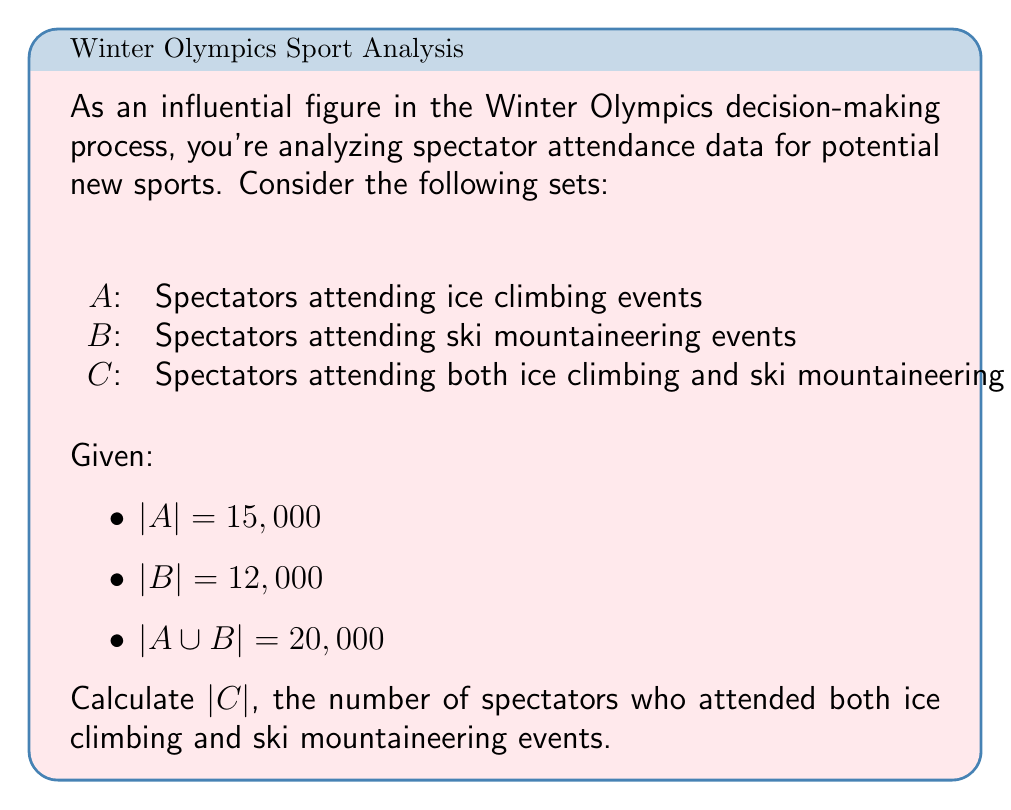Give your solution to this math problem. To solve this problem, we'll use the principle of inclusion-exclusion for two sets:

1) The formula for the union of two sets is:
   $|A \cup B| = |A| + |B| - |A \cap B|$

2) We know that $C = A \cap B$, so we need to find $|A \cap B|$

3) Rearranging the formula:
   $|A \cap B| = |A| + |B| - |A \cup B|$

4) Substituting the given values:
   $|C| = |A \cap B| = 15,000 + 12,000 - 20,000$

5) Calculating:
   $|C| = 27,000 - 20,000 = 7,000$

Therefore, 7,000 spectators attended both ice climbing and ski mountaineering events.
Answer: 7,000 